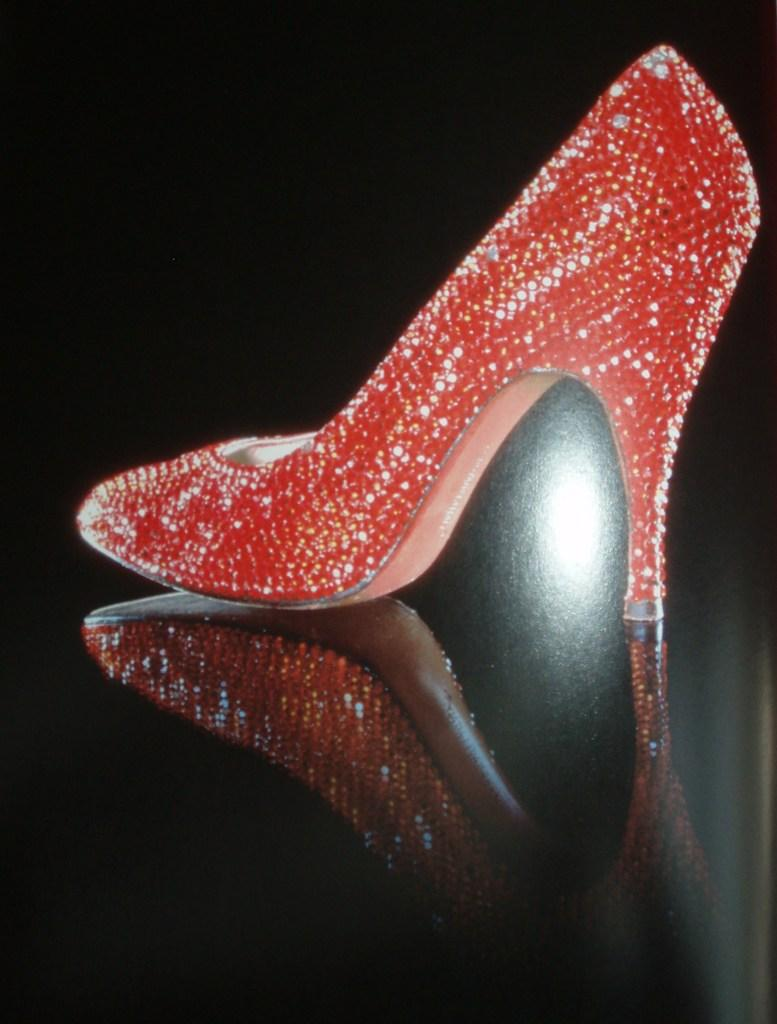What type of shoe is in the center of the image? There is a red color heel in the center of the image. Can you describe the position of the heel in the image? The heel is in the center of the image. What type of grass can be seen growing in the cellar near the key in the image? There is no grass, cellar, or key present in the image; it only features a red color heel in the center. 